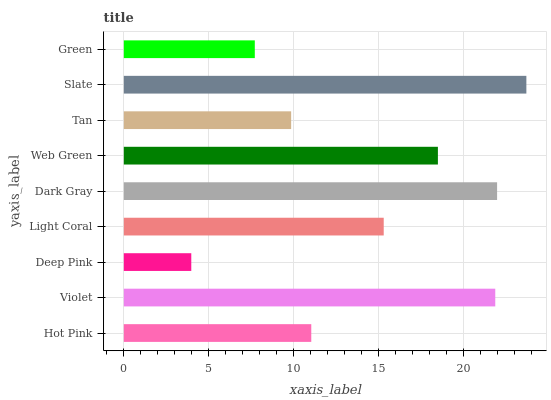Is Deep Pink the minimum?
Answer yes or no. Yes. Is Slate the maximum?
Answer yes or no. Yes. Is Violet the minimum?
Answer yes or no. No. Is Violet the maximum?
Answer yes or no. No. Is Violet greater than Hot Pink?
Answer yes or no. Yes. Is Hot Pink less than Violet?
Answer yes or no. Yes. Is Hot Pink greater than Violet?
Answer yes or no. No. Is Violet less than Hot Pink?
Answer yes or no. No. Is Light Coral the high median?
Answer yes or no. Yes. Is Light Coral the low median?
Answer yes or no. Yes. Is Deep Pink the high median?
Answer yes or no. No. Is Tan the low median?
Answer yes or no. No. 